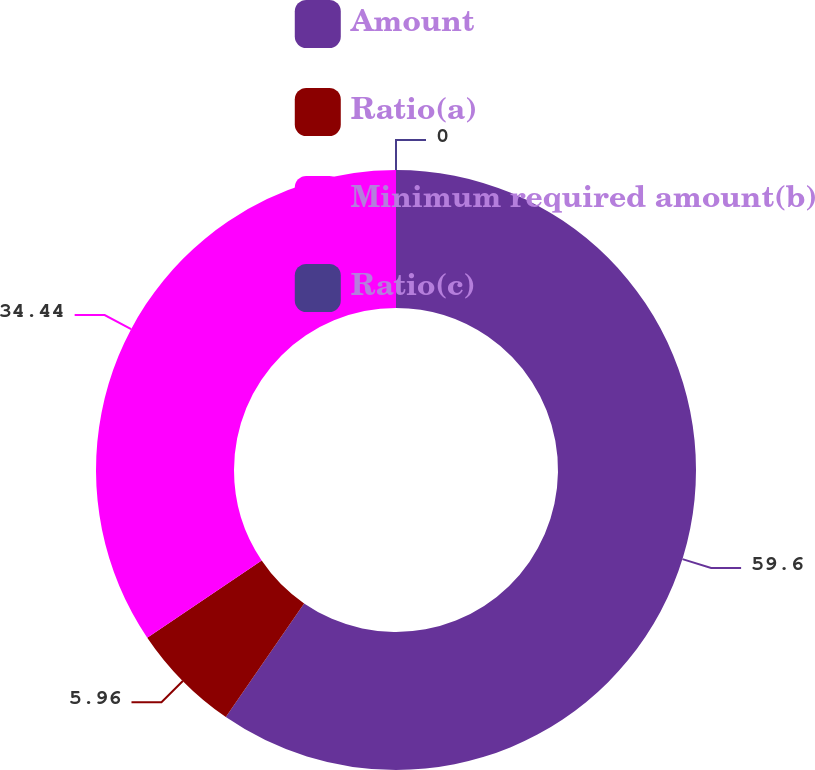Convert chart. <chart><loc_0><loc_0><loc_500><loc_500><pie_chart><fcel>Amount<fcel>Ratio(a)<fcel>Minimum required amount(b)<fcel>Ratio(c)<nl><fcel>59.6%<fcel>5.96%<fcel>34.44%<fcel>0.0%<nl></chart> 